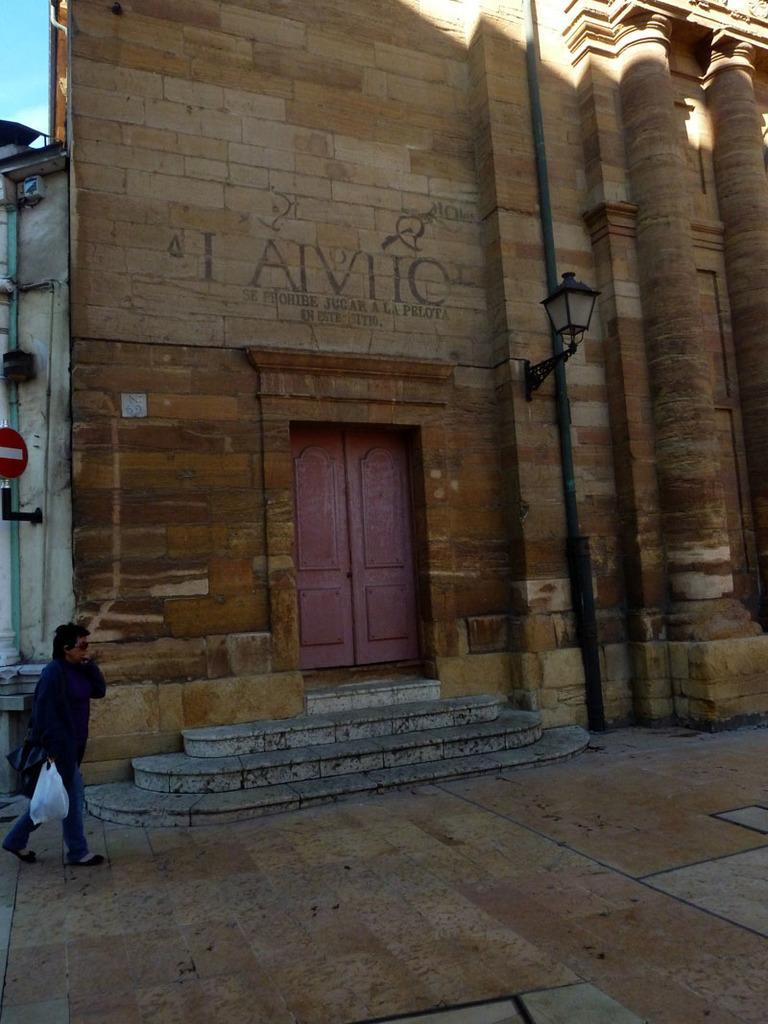In one or two sentences, can you explain what this image depicts? In this image I can see a person walking holding a clover and the cover is in white color, background I can see a building in brown color and sky in blue color. 